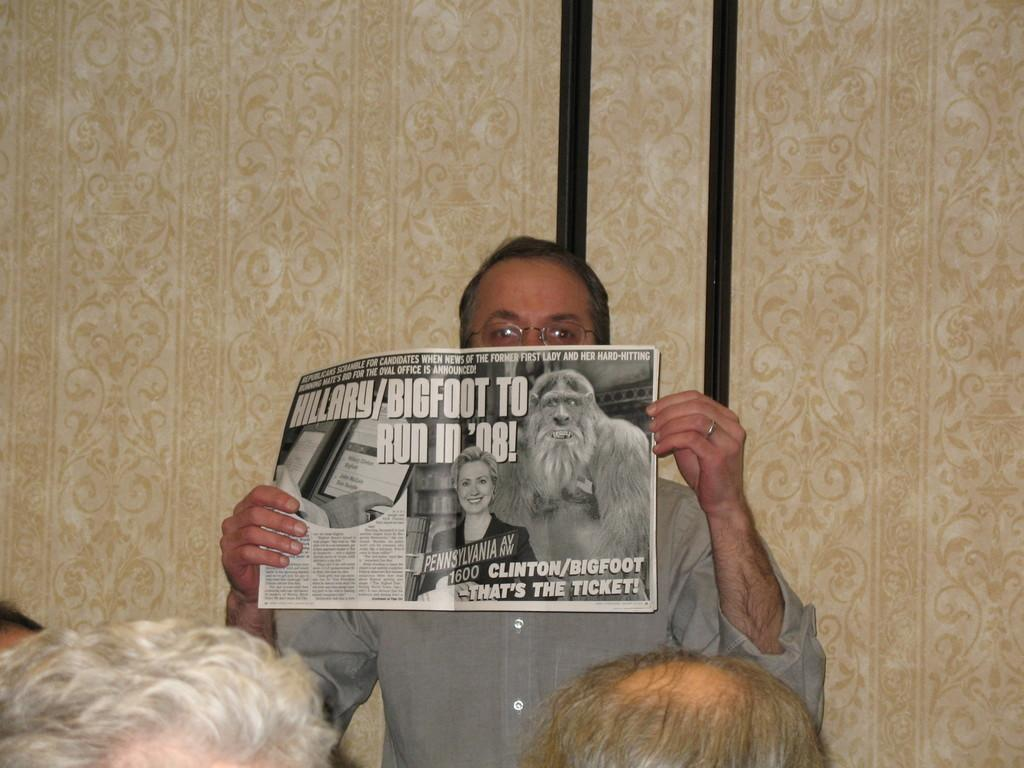Who is the main subject in the image? There is a man in the center of the image. What is the man holding in the image? The man is holding a poster. Are there any other people visible in the image? Yes, there are other people at the bottom side of the image. What type of sweater is the man wearing in the image? The provided facts do not mention any clothing the man is wearing, so we cannot determine if he is wearing a sweater or its type. 